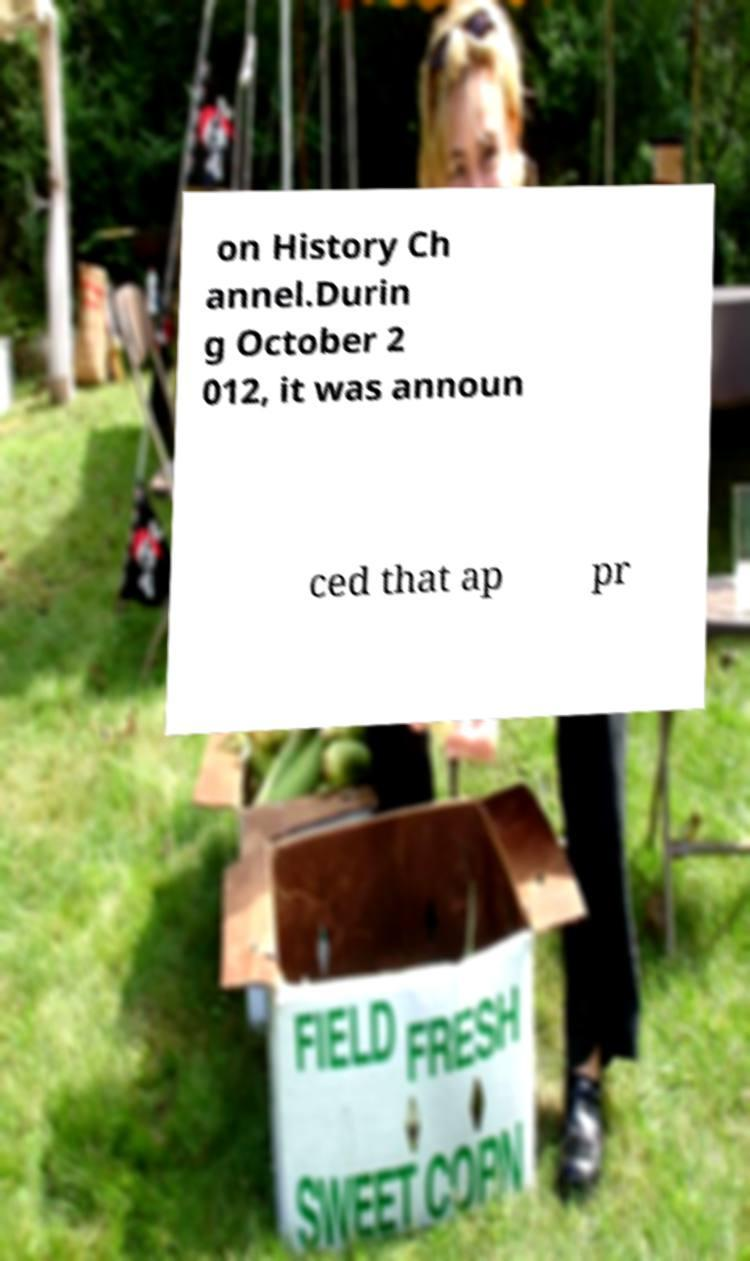Can you read and provide the text displayed in the image?This photo seems to have some interesting text. Can you extract and type it out for me? on History Ch annel.Durin g October 2 012, it was announ ced that ap pr 